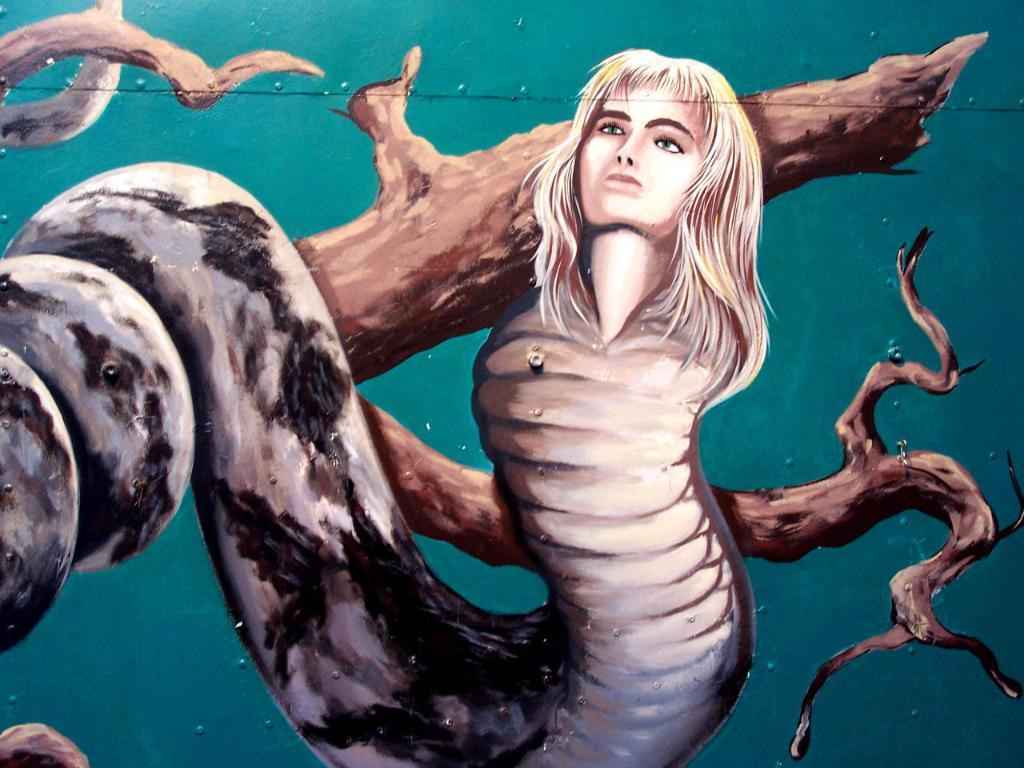What is the main object in the image? There is a tree trunk in the image. Are there any living beings in the image? Yes, there is a woman with a snake body in the image. How much dust can be seen on the base of the tree trunk in the image? There is no mention of dust in the image, so it cannot be determined how much dust is present on the base of the tree trunk. 